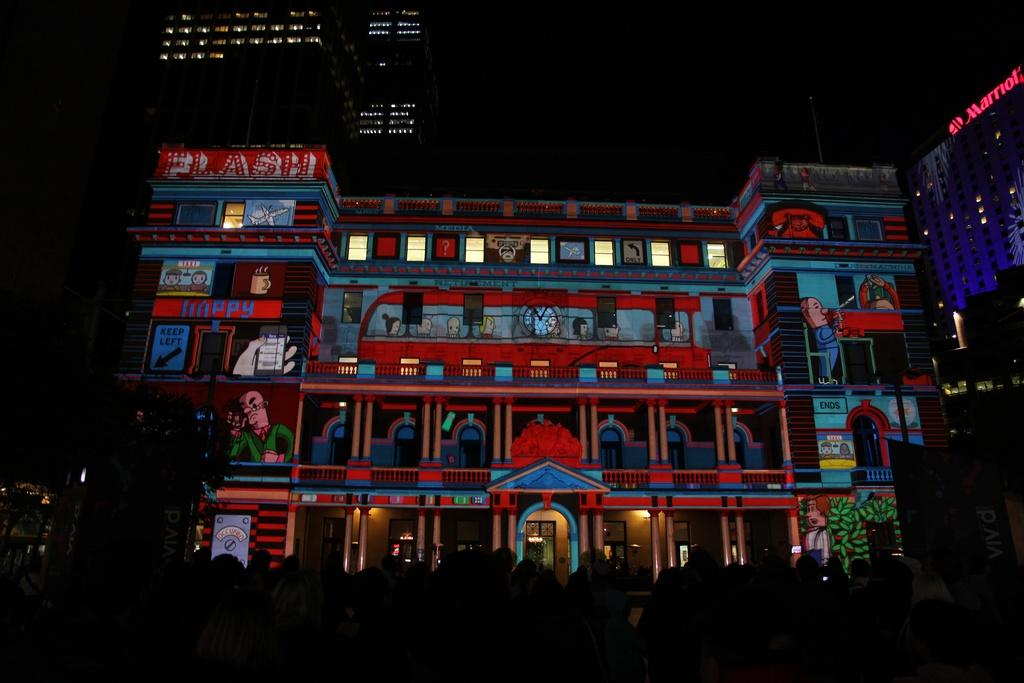What type of structures can be seen in the image? There are buildings in the image. What part of the natural environment is visible in the image? Trees are visible in the image. What type of lighting is present in the image? Electric lights are present in the image. What is the condition of the sky in the image? The sky is visible in the image. What are the people in the image doing? Persons are standing on the ground in the image. Can you tell me what type of creature the judge is representing in the image? There is no judge or representative present in the image. What type of creature is standing next to the representative in the image? There is no creature or representative present in the image. 